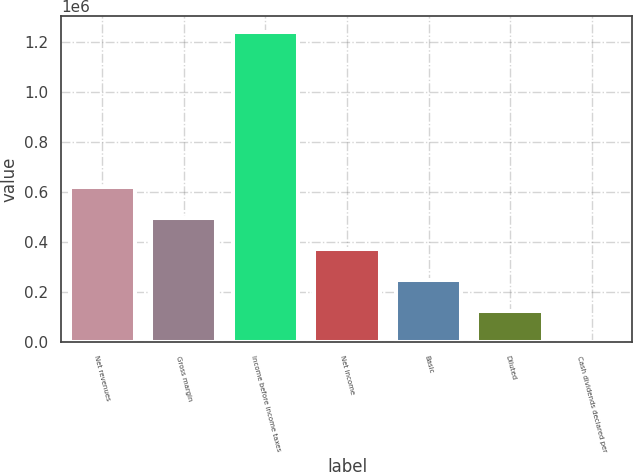<chart> <loc_0><loc_0><loc_500><loc_500><bar_chart><fcel>Net revenues<fcel>Gross margin<fcel>Income before income taxes<fcel>Net income<fcel>Basic<fcel>Diluted<fcel>Cash dividends declared per<nl><fcel>620741<fcel>496592<fcel>1.24148e+06<fcel>372444<fcel>248296<fcel>124148<fcel>0.05<nl></chart> 